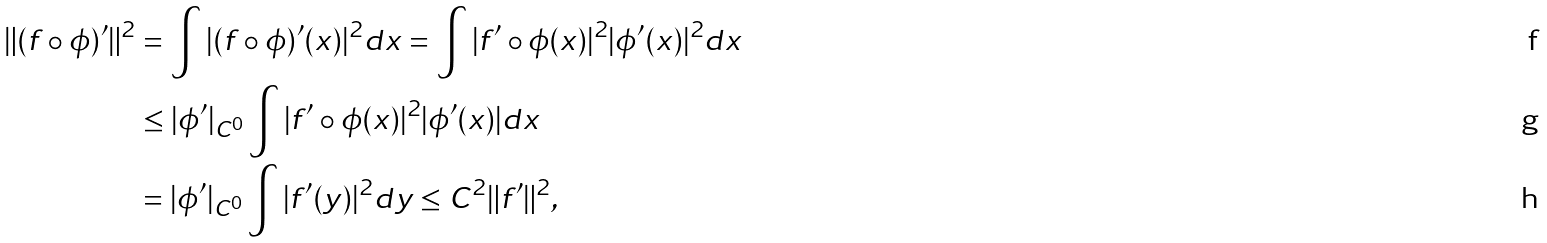Convert formula to latex. <formula><loc_0><loc_0><loc_500><loc_500>\| ( f \circ \phi ) ^ { \prime } \| ^ { 2 } & = \int | ( f \circ \phi ) ^ { \prime } ( x ) | ^ { 2 } d x = \int | f ^ { \prime } \circ \phi ( x ) | ^ { 2 } | \phi ^ { \prime } ( x ) | ^ { 2 } d x \\ & \leq | \phi ^ { \prime } | _ { C ^ { 0 } } \int | f ^ { \prime } \circ \phi ( x ) | ^ { 2 } | \phi ^ { \prime } ( x ) | d x \\ & = | \phi ^ { \prime } | _ { C ^ { 0 } } \int | f ^ { \prime } ( y ) | ^ { 2 } d y \leq C ^ { 2 } \| f ^ { \prime } \| ^ { 2 } ,</formula> 